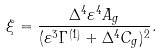<formula> <loc_0><loc_0><loc_500><loc_500>\xi = \frac { \Delta ^ { 4 } \varepsilon ^ { 4 } A _ { g } } { ( \varepsilon ^ { 3 } \Gamma ^ { ( 1 ) } + \Delta ^ { 4 } C _ { g } ) ^ { 2 } } .</formula> 